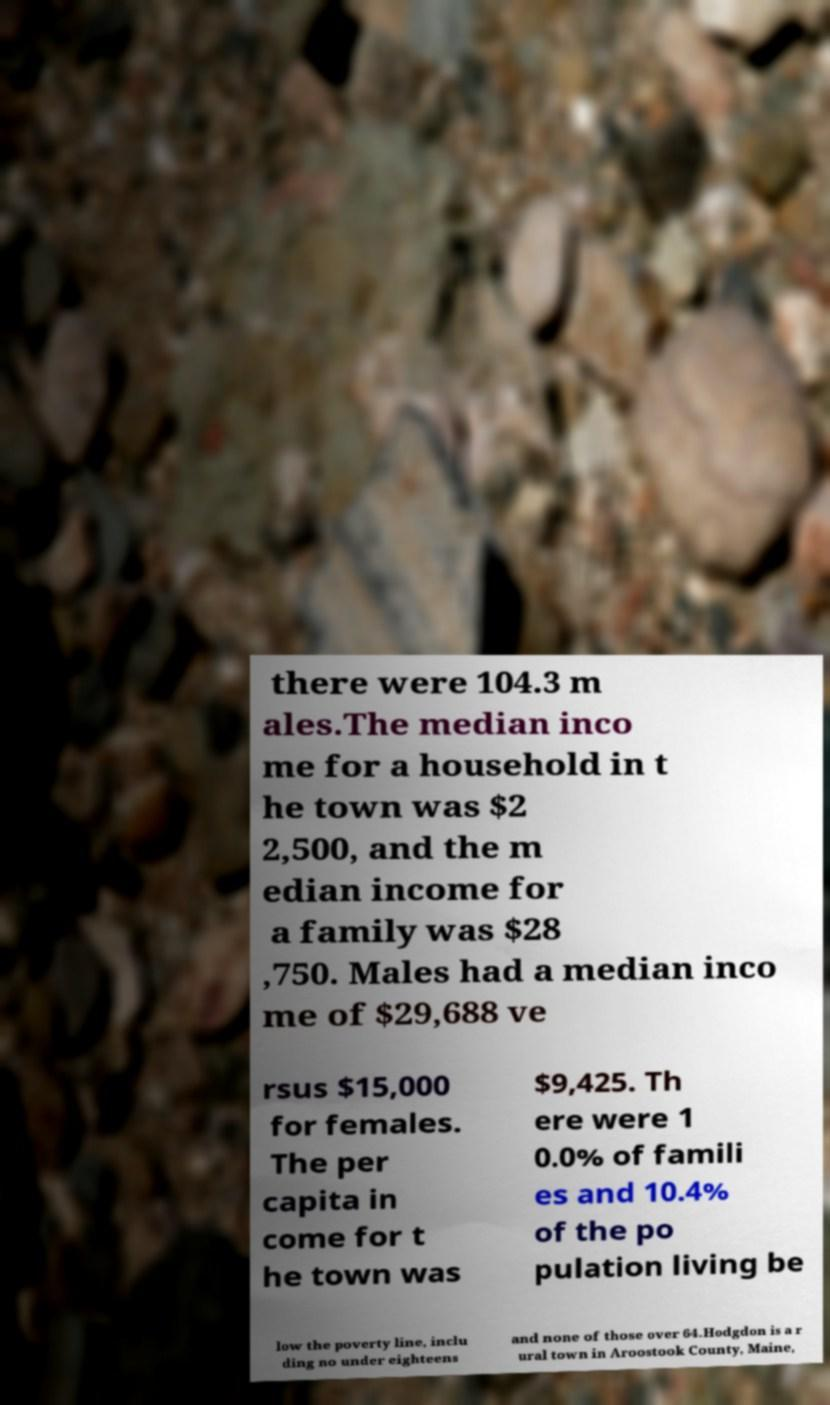Please identify and transcribe the text found in this image. there were 104.3 m ales.The median inco me for a household in t he town was $2 2,500, and the m edian income for a family was $28 ,750. Males had a median inco me of $29,688 ve rsus $15,000 for females. The per capita in come for t he town was $9,425. Th ere were 1 0.0% of famili es and 10.4% of the po pulation living be low the poverty line, inclu ding no under eighteens and none of those over 64.Hodgdon is a r ural town in Aroostook County, Maine, 